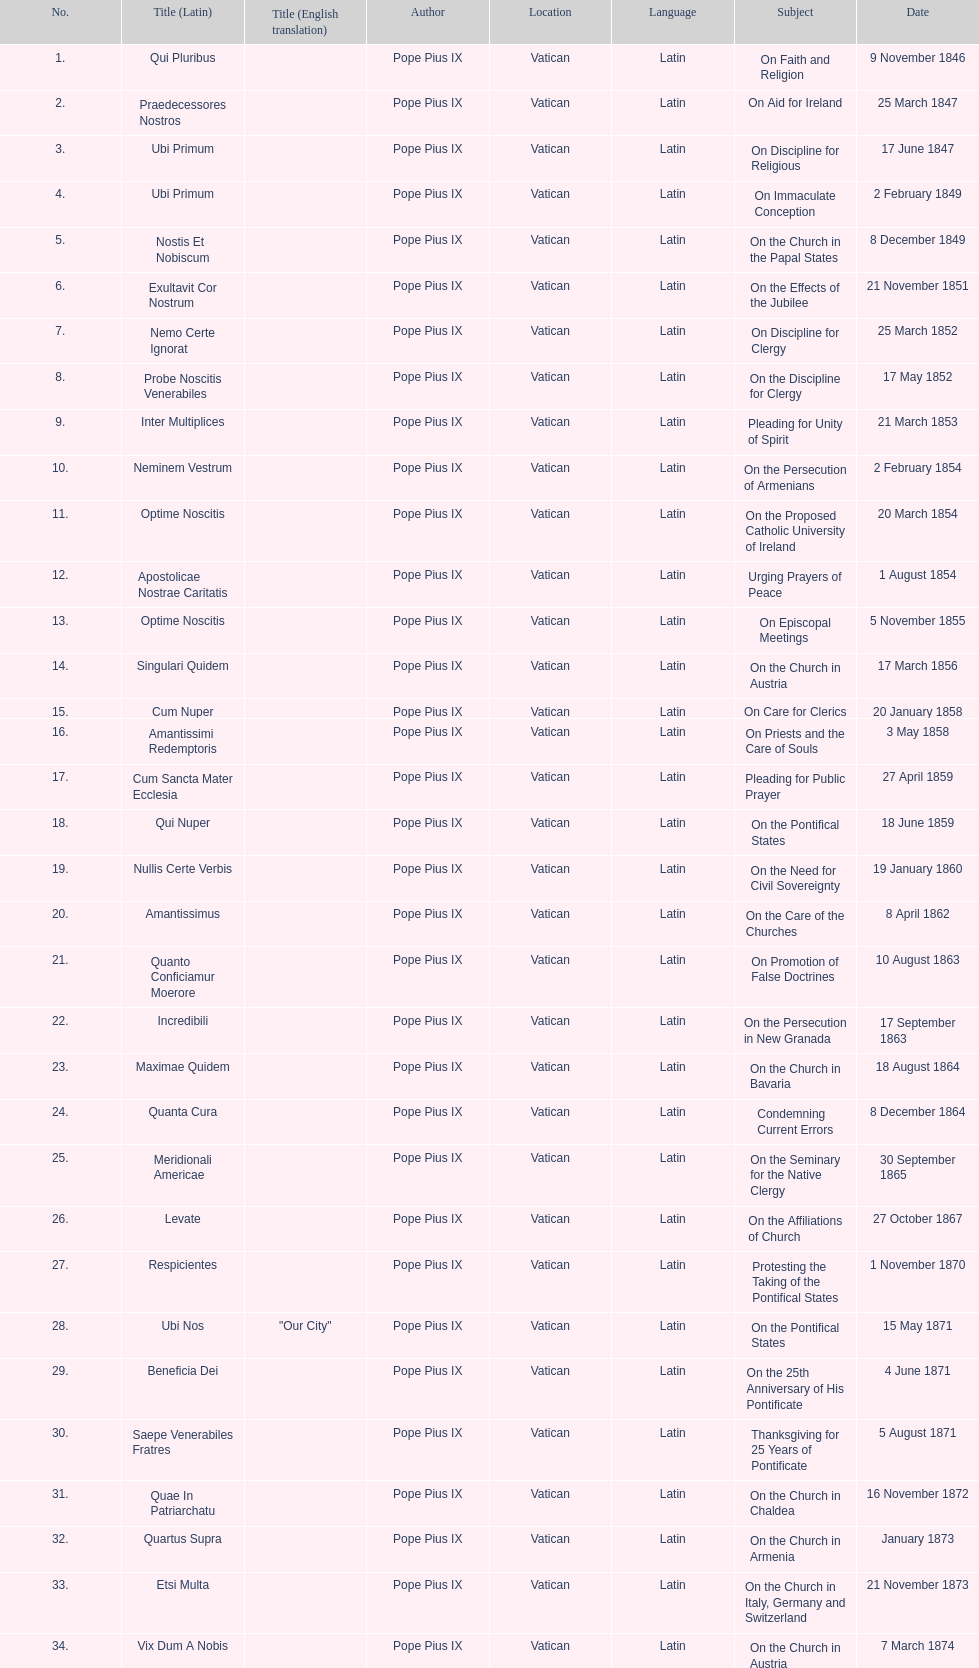What is the previous subject after on the effects of the jubilee? On the Church in the Papal States. 